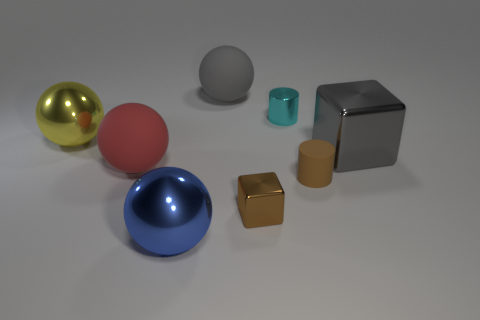Are there more blue shiny objects than gray objects?
Offer a terse response. No. What shape is the large matte object that is on the left side of the big sphere that is behind the yellow object?
Your response must be concise. Sphere. Is the tiny cube the same color as the small matte object?
Your answer should be very brief. Yes. Are there more rubber cylinders that are on the left side of the cyan metallic thing than yellow shiny objects?
Your response must be concise. No. There is a block right of the small brown metallic object; what number of tiny shiny cylinders are in front of it?
Ensure brevity in your answer.  0. Is the material of the block right of the brown matte cylinder the same as the small brown object right of the brown metal cube?
Provide a succinct answer. No. What material is the cylinder that is the same color as the small cube?
Provide a short and direct response. Rubber. How many other cyan things have the same shape as the small rubber object?
Ensure brevity in your answer.  1. Is the material of the blue sphere the same as the sphere to the right of the large blue sphere?
Give a very brief answer. No. There is a yellow thing that is the same size as the gray ball; what is its material?
Provide a succinct answer. Metal. 